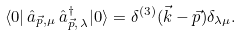<formula> <loc_0><loc_0><loc_500><loc_500>\langle 0 | \, \hat { a } _ { \vec { p } , \mu } \, \hat { a } ^ { \dagger } _ { \vec { p } , \, \lambda } | 0 \rangle = \delta ^ { ( 3 ) } ( \vec { k } - \vec { p } ) \delta _ { \lambda \mu } .</formula> 